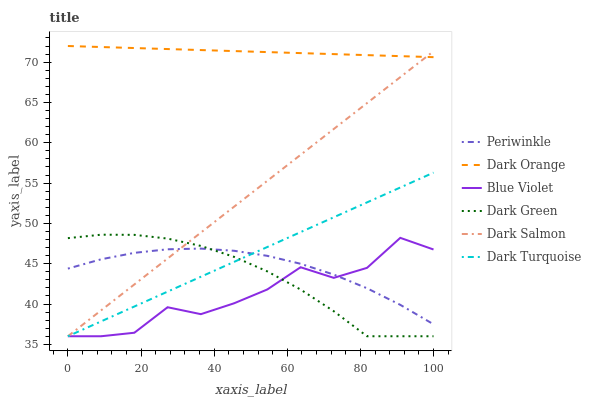Does Blue Violet have the minimum area under the curve?
Answer yes or no. Yes. Does Dark Orange have the maximum area under the curve?
Answer yes or no. Yes. Does Dark Turquoise have the minimum area under the curve?
Answer yes or no. No. Does Dark Turquoise have the maximum area under the curve?
Answer yes or no. No. Is Dark Orange the smoothest?
Answer yes or no. Yes. Is Blue Violet the roughest?
Answer yes or no. Yes. Is Dark Turquoise the smoothest?
Answer yes or no. No. Is Dark Turquoise the roughest?
Answer yes or no. No. Does Dark Turquoise have the lowest value?
Answer yes or no. Yes. Does Periwinkle have the lowest value?
Answer yes or no. No. Does Dark Orange have the highest value?
Answer yes or no. Yes. Does Dark Turquoise have the highest value?
Answer yes or no. No. Is Dark Turquoise less than Dark Orange?
Answer yes or no. Yes. Is Dark Orange greater than Dark Turquoise?
Answer yes or no. Yes. Does Dark Salmon intersect Dark Turquoise?
Answer yes or no. Yes. Is Dark Salmon less than Dark Turquoise?
Answer yes or no. No. Is Dark Salmon greater than Dark Turquoise?
Answer yes or no. No. Does Dark Turquoise intersect Dark Orange?
Answer yes or no. No. 